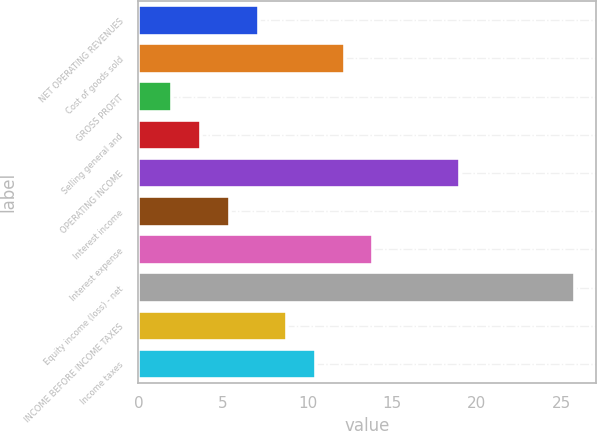Convert chart. <chart><loc_0><loc_0><loc_500><loc_500><bar_chart><fcel>NET OPERATING REVENUES<fcel>Cost of goods sold<fcel>GROSS PROFIT<fcel>Selling general and<fcel>OPERATING INCOME<fcel>Interest income<fcel>Interest expense<fcel>Equity income (loss) - net<fcel>INCOME BEFORE INCOME TAXES<fcel>Income taxes<nl><fcel>7.1<fcel>12.2<fcel>2<fcel>3.7<fcel>19<fcel>5.4<fcel>13.9<fcel>25.8<fcel>8.8<fcel>10.5<nl></chart> 